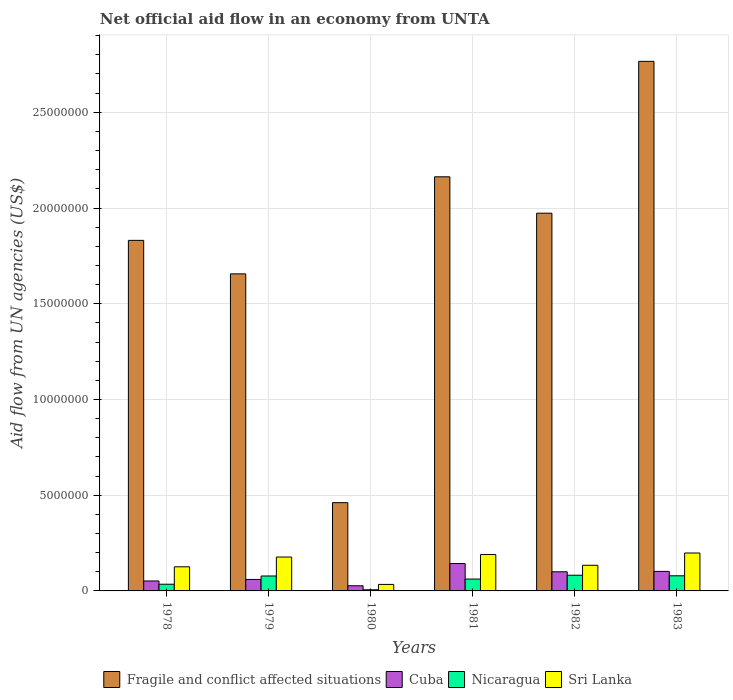Are the number of bars on each tick of the X-axis equal?
Offer a terse response. Yes. How many bars are there on the 5th tick from the left?
Give a very brief answer. 4. How many bars are there on the 3rd tick from the right?
Make the answer very short. 4. What is the label of the 2nd group of bars from the left?
Offer a terse response. 1979. What is the net official aid flow in Fragile and conflict affected situations in 1978?
Ensure brevity in your answer.  1.83e+07. Across all years, what is the maximum net official aid flow in Sri Lanka?
Give a very brief answer. 1.98e+06. Across all years, what is the minimum net official aid flow in Fragile and conflict affected situations?
Keep it short and to the point. 4.61e+06. In which year was the net official aid flow in Nicaragua maximum?
Provide a short and direct response. 1982. In which year was the net official aid flow in Nicaragua minimum?
Your answer should be compact. 1980. What is the total net official aid flow in Nicaragua in the graph?
Offer a very short reply. 3.42e+06. What is the difference between the net official aid flow in Nicaragua in 1980 and that in 1982?
Your answer should be compact. -7.60e+05. What is the difference between the net official aid flow in Fragile and conflict affected situations in 1980 and the net official aid flow in Cuba in 1979?
Provide a short and direct response. 4.01e+06. What is the average net official aid flow in Sri Lanka per year?
Your answer should be compact. 1.43e+06. In the year 1981, what is the difference between the net official aid flow in Cuba and net official aid flow in Fragile and conflict affected situations?
Offer a terse response. -2.02e+07. What is the ratio of the net official aid flow in Sri Lanka in 1980 to that in 1983?
Ensure brevity in your answer.  0.17. Is the net official aid flow in Sri Lanka in 1978 less than that in 1979?
Provide a succinct answer. Yes. What is the difference between the highest and the second highest net official aid flow in Sri Lanka?
Offer a very short reply. 8.00e+04. What is the difference between the highest and the lowest net official aid flow in Cuba?
Your response must be concise. 1.16e+06. Is the sum of the net official aid flow in Nicaragua in 1980 and 1981 greater than the maximum net official aid flow in Sri Lanka across all years?
Your response must be concise. No. Is it the case that in every year, the sum of the net official aid flow in Cuba and net official aid flow in Fragile and conflict affected situations is greater than the sum of net official aid flow in Sri Lanka and net official aid flow in Nicaragua?
Offer a terse response. No. What does the 2nd bar from the left in 1983 represents?
Your response must be concise. Cuba. What does the 1st bar from the right in 1981 represents?
Keep it short and to the point. Sri Lanka. How many bars are there?
Ensure brevity in your answer.  24. Are all the bars in the graph horizontal?
Your response must be concise. No. How many years are there in the graph?
Ensure brevity in your answer.  6. What is the difference between two consecutive major ticks on the Y-axis?
Give a very brief answer. 5.00e+06. Does the graph contain any zero values?
Your response must be concise. No. Does the graph contain grids?
Ensure brevity in your answer.  Yes. Where does the legend appear in the graph?
Make the answer very short. Bottom center. How many legend labels are there?
Keep it short and to the point. 4. How are the legend labels stacked?
Your answer should be compact. Horizontal. What is the title of the graph?
Provide a short and direct response. Net official aid flow in an economy from UNTA. Does "Guinea-Bissau" appear as one of the legend labels in the graph?
Your response must be concise. No. What is the label or title of the Y-axis?
Ensure brevity in your answer.  Aid flow from UN agencies (US$). What is the Aid flow from UN agencies (US$) of Fragile and conflict affected situations in 1978?
Offer a terse response. 1.83e+07. What is the Aid flow from UN agencies (US$) of Cuba in 1978?
Ensure brevity in your answer.  5.20e+05. What is the Aid flow from UN agencies (US$) of Sri Lanka in 1978?
Make the answer very short. 1.26e+06. What is the Aid flow from UN agencies (US$) of Fragile and conflict affected situations in 1979?
Ensure brevity in your answer.  1.66e+07. What is the Aid flow from UN agencies (US$) in Nicaragua in 1979?
Ensure brevity in your answer.  7.80e+05. What is the Aid flow from UN agencies (US$) in Sri Lanka in 1979?
Ensure brevity in your answer.  1.77e+06. What is the Aid flow from UN agencies (US$) in Fragile and conflict affected situations in 1980?
Make the answer very short. 4.61e+06. What is the Aid flow from UN agencies (US$) in Sri Lanka in 1980?
Your answer should be very brief. 3.40e+05. What is the Aid flow from UN agencies (US$) of Fragile and conflict affected situations in 1981?
Ensure brevity in your answer.  2.16e+07. What is the Aid flow from UN agencies (US$) in Cuba in 1981?
Keep it short and to the point. 1.43e+06. What is the Aid flow from UN agencies (US$) in Nicaragua in 1981?
Provide a succinct answer. 6.20e+05. What is the Aid flow from UN agencies (US$) of Sri Lanka in 1981?
Give a very brief answer. 1.90e+06. What is the Aid flow from UN agencies (US$) in Fragile and conflict affected situations in 1982?
Make the answer very short. 1.97e+07. What is the Aid flow from UN agencies (US$) in Cuba in 1982?
Provide a succinct answer. 1.00e+06. What is the Aid flow from UN agencies (US$) in Nicaragua in 1982?
Provide a succinct answer. 8.20e+05. What is the Aid flow from UN agencies (US$) of Sri Lanka in 1982?
Make the answer very short. 1.34e+06. What is the Aid flow from UN agencies (US$) of Fragile and conflict affected situations in 1983?
Your answer should be very brief. 2.77e+07. What is the Aid flow from UN agencies (US$) in Cuba in 1983?
Your answer should be very brief. 1.02e+06. What is the Aid flow from UN agencies (US$) of Nicaragua in 1983?
Keep it short and to the point. 7.90e+05. What is the Aid flow from UN agencies (US$) in Sri Lanka in 1983?
Keep it short and to the point. 1.98e+06. Across all years, what is the maximum Aid flow from UN agencies (US$) in Fragile and conflict affected situations?
Offer a very short reply. 2.77e+07. Across all years, what is the maximum Aid flow from UN agencies (US$) of Cuba?
Keep it short and to the point. 1.43e+06. Across all years, what is the maximum Aid flow from UN agencies (US$) in Nicaragua?
Offer a very short reply. 8.20e+05. Across all years, what is the maximum Aid flow from UN agencies (US$) in Sri Lanka?
Provide a succinct answer. 1.98e+06. Across all years, what is the minimum Aid flow from UN agencies (US$) in Fragile and conflict affected situations?
Your answer should be compact. 4.61e+06. Across all years, what is the minimum Aid flow from UN agencies (US$) of Nicaragua?
Provide a short and direct response. 6.00e+04. What is the total Aid flow from UN agencies (US$) of Fragile and conflict affected situations in the graph?
Your response must be concise. 1.08e+08. What is the total Aid flow from UN agencies (US$) in Cuba in the graph?
Offer a very short reply. 4.84e+06. What is the total Aid flow from UN agencies (US$) in Nicaragua in the graph?
Your answer should be compact. 3.42e+06. What is the total Aid flow from UN agencies (US$) in Sri Lanka in the graph?
Offer a very short reply. 8.59e+06. What is the difference between the Aid flow from UN agencies (US$) of Fragile and conflict affected situations in 1978 and that in 1979?
Make the answer very short. 1.75e+06. What is the difference between the Aid flow from UN agencies (US$) of Cuba in 1978 and that in 1979?
Your response must be concise. -8.00e+04. What is the difference between the Aid flow from UN agencies (US$) of Nicaragua in 1978 and that in 1979?
Provide a short and direct response. -4.30e+05. What is the difference between the Aid flow from UN agencies (US$) of Sri Lanka in 1978 and that in 1979?
Provide a succinct answer. -5.10e+05. What is the difference between the Aid flow from UN agencies (US$) of Fragile and conflict affected situations in 1978 and that in 1980?
Keep it short and to the point. 1.37e+07. What is the difference between the Aid flow from UN agencies (US$) in Sri Lanka in 1978 and that in 1980?
Ensure brevity in your answer.  9.20e+05. What is the difference between the Aid flow from UN agencies (US$) in Fragile and conflict affected situations in 1978 and that in 1981?
Your response must be concise. -3.32e+06. What is the difference between the Aid flow from UN agencies (US$) in Cuba in 1978 and that in 1981?
Make the answer very short. -9.10e+05. What is the difference between the Aid flow from UN agencies (US$) of Nicaragua in 1978 and that in 1981?
Make the answer very short. -2.70e+05. What is the difference between the Aid flow from UN agencies (US$) in Sri Lanka in 1978 and that in 1981?
Give a very brief answer. -6.40e+05. What is the difference between the Aid flow from UN agencies (US$) of Fragile and conflict affected situations in 1978 and that in 1982?
Give a very brief answer. -1.42e+06. What is the difference between the Aid flow from UN agencies (US$) of Cuba in 1978 and that in 1982?
Make the answer very short. -4.80e+05. What is the difference between the Aid flow from UN agencies (US$) in Nicaragua in 1978 and that in 1982?
Keep it short and to the point. -4.70e+05. What is the difference between the Aid flow from UN agencies (US$) in Fragile and conflict affected situations in 1978 and that in 1983?
Your answer should be compact. -9.35e+06. What is the difference between the Aid flow from UN agencies (US$) of Cuba in 1978 and that in 1983?
Your answer should be compact. -5.00e+05. What is the difference between the Aid flow from UN agencies (US$) in Nicaragua in 1978 and that in 1983?
Your answer should be compact. -4.40e+05. What is the difference between the Aid flow from UN agencies (US$) of Sri Lanka in 1978 and that in 1983?
Ensure brevity in your answer.  -7.20e+05. What is the difference between the Aid flow from UN agencies (US$) in Fragile and conflict affected situations in 1979 and that in 1980?
Offer a very short reply. 1.20e+07. What is the difference between the Aid flow from UN agencies (US$) of Nicaragua in 1979 and that in 1980?
Provide a short and direct response. 7.20e+05. What is the difference between the Aid flow from UN agencies (US$) of Sri Lanka in 1979 and that in 1980?
Make the answer very short. 1.43e+06. What is the difference between the Aid flow from UN agencies (US$) of Fragile and conflict affected situations in 1979 and that in 1981?
Your answer should be very brief. -5.07e+06. What is the difference between the Aid flow from UN agencies (US$) of Cuba in 1979 and that in 1981?
Your answer should be very brief. -8.30e+05. What is the difference between the Aid flow from UN agencies (US$) of Sri Lanka in 1979 and that in 1981?
Provide a short and direct response. -1.30e+05. What is the difference between the Aid flow from UN agencies (US$) in Fragile and conflict affected situations in 1979 and that in 1982?
Offer a very short reply. -3.17e+06. What is the difference between the Aid flow from UN agencies (US$) in Cuba in 1979 and that in 1982?
Provide a short and direct response. -4.00e+05. What is the difference between the Aid flow from UN agencies (US$) of Sri Lanka in 1979 and that in 1982?
Give a very brief answer. 4.30e+05. What is the difference between the Aid flow from UN agencies (US$) of Fragile and conflict affected situations in 1979 and that in 1983?
Your response must be concise. -1.11e+07. What is the difference between the Aid flow from UN agencies (US$) of Cuba in 1979 and that in 1983?
Offer a very short reply. -4.20e+05. What is the difference between the Aid flow from UN agencies (US$) in Nicaragua in 1979 and that in 1983?
Your response must be concise. -10000. What is the difference between the Aid flow from UN agencies (US$) in Fragile and conflict affected situations in 1980 and that in 1981?
Give a very brief answer. -1.70e+07. What is the difference between the Aid flow from UN agencies (US$) in Cuba in 1980 and that in 1981?
Ensure brevity in your answer.  -1.16e+06. What is the difference between the Aid flow from UN agencies (US$) of Nicaragua in 1980 and that in 1981?
Your answer should be very brief. -5.60e+05. What is the difference between the Aid flow from UN agencies (US$) of Sri Lanka in 1980 and that in 1981?
Offer a terse response. -1.56e+06. What is the difference between the Aid flow from UN agencies (US$) of Fragile and conflict affected situations in 1980 and that in 1982?
Ensure brevity in your answer.  -1.51e+07. What is the difference between the Aid flow from UN agencies (US$) in Cuba in 1980 and that in 1982?
Offer a terse response. -7.30e+05. What is the difference between the Aid flow from UN agencies (US$) of Nicaragua in 1980 and that in 1982?
Your response must be concise. -7.60e+05. What is the difference between the Aid flow from UN agencies (US$) in Fragile and conflict affected situations in 1980 and that in 1983?
Ensure brevity in your answer.  -2.30e+07. What is the difference between the Aid flow from UN agencies (US$) of Cuba in 1980 and that in 1983?
Provide a short and direct response. -7.50e+05. What is the difference between the Aid flow from UN agencies (US$) in Nicaragua in 1980 and that in 1983?
Provide a short and direct response. -7.30e+05. What is the difference between the Aid flow from UN agencies (US$) of Sri Lanka in 1980 and that in 1983?
Your answer should be compact. -1.64e+06. What is the difference between the Aid flow from UN agencies (US$) of Fragile and conflict affected situations in 1981 and that in 1982?
Your answer should be compact. 1.90e+06. What is the difference between the Aid flow from UN agencies (US$) in Cuba in 1981 and that in 1982?
Provide a short and direct response. 4.30e+05. What is the difference between the Aid flow from UN agencies (US$) in Nicaragua in 1981 and that in 1982?
Ensure brevity in your answer.  -2.00e+05. What is the difference between the Aid flow from UN agencies (US$) in Sri Lanka in 1981 and that in 1982?
Make the answer very short. 5.60e+05. What is the difference between the Aid flow from UN agencies (US$) in Fragile and conflict affected situations in 1981 and that in 1983?
Provide a succinct answer. -6.03e+06. What is the difference between the Aid flow from UN agencies (US$) of Sri Lanka in 1981 and that in 1983?
Your answer should be very brief. -8.00e+04. What is the difference between the Aid flow from UN agencies (US$) in Fragile and conflict affected situations in 1982 and that in 1983?
Provide a short and direct response. -7.93e+06. What is the difference between the Aid flow from UN agencies (US$) of Cuba in 1982 and that in 1983?
Your response must be concise. -2.00e+04. What is the difference between the Aid flow from UN agencies (US$) in Nicaragua in 1982 and that in 1983?
Offer a very short reply. 3.00e+04. What is the difference between the Aid flow from UN agencies (US$) in Sri Lanka in 1982 and that in 1983?
Offer a terse response. -6.40e+05. What is the difference between the Aid flow from UN agencies (US$) in Fragile and conflict affected situations in 1978 and the Aid flow from UN agencies (US$) in Cuba in 1979?
Offer a terse response. 1.77e+07. What is the difference between the Aid flow from UN agencies (US$) of Fragile and conflict affected situations in 1978 and the Aid flow from UN agencies (US$) of Nicaragua in 1979?
Your response must be concise. 1.75e+07. What is the difference between the Aid flow from UN agencies (US$) in Fragile and conflict affected situations in 1978 and the Aid flow from UN agencies (US$) in Sri Lanka in 1979?
Offer a very short reply. 1.65e+07. What is the difference between the Aid flow from UN agencies (US$) of Cuba in 1978 and the Aid flow from UN agencies (US$) of Nicaragua in 1979?
Make the answer very short. -2.60e+05. What is the difference between the Aid flow from UN agencies (US$) in Cuba in 1978 and the Aid flow from UN agencies (US$) in Sri Lanka in 1979?
Offer a terse response. -1.25e+06. What is the difference between the Aid flow from UN agencies (US$) in Nicaragua in 1978 and the Aid flow from UN agencies (US$) in Sri Lanka in 1979?
Your response must be concise. -1.42e+06. What is the difference between the Aid flow from UN agencies (US$) in Fragile and conflict affected situations in 1978 and the Aid flow from UN agencies (US$) in Cuba in 1980?
Offer a very short reply. 1.80e+07. What is the difference between the Aid flow from UN agencies (US$) in Fragile and conflict affected situations in 1978 and the Aid flow from UN agencies (US$) in Nicaragua in 1980?
Give a very brief answer. 1.82e+07. What is the difference between the Aid flow from UN agencies (US$) in Fragile and conflict affected situations in 1978 and the Aid flow from UN agencies (US$) in Sri Lanka in 1980?
Provide a short and direct response. 1.80e+07. What is the difference between the Aid flow from UN agencies (US$) in Cuba in 1978 and the Aid flow from UN agencies (US$) in Sri Lanka in 1980?
Ensure brevity in your answer.  1.80e+05. What is the difference between the Aid flow from UN agencies (US$) of Fragile and conflict affected situations in 1978 and the Aid flow from UN agencies (US$) of Cuba in 1981?
Provide a succinct answer. 1.69e+07. What is the difference between the Aid flow from UN agencies (US$) in Fragile and conflict affected situations in 1978 and the Aid flow from UN agencies (US$) in Nicaragua in 1981?
Keep it short and to the point. 1.77e+07. What is the difference between the Aid flow from UN agencies (US$) in Fragile and conflict affected situations in 1978 and the Aid flow from UN agencies (US$) in Sri Lanka in 1981?
Keep it short and to the point. 1.64e+07. What is the difference between the Aid flow from UN agencies (US$) in Cuba in 1978 and the Aid flow from UN agencies (US$) in Nicaragua in 1981?
Provide a short and direct response. -1.00e+05. What is the difference between the Aid flow from UN agencies (US$) in Cuba in 1978 and the Aid flow from UN agencies (US$) in Sri Lanka in 1981?
Provide a succinct answer. -1.38e+06. What is the difference between the Aid flow from UN agencies (US$) in Nicaragua in 1978 and the Aid flow from UN agencies (US$) in Sri Lanka in 1981?
Your answer should be very brief. -1.55e+06. What is the difference between the Aid flow from UN agencies (US$) of Fragile and conflict affected situations in 1978 and the Aid flow from UN agencies (US$) of Cuba in 1982?
Your answer should be compact. 1.73e+07. What is the difference between the Aid flow from UN agencies (US$) of Fragile and conflict affected situations in 1978 and the Aid flow from UN agencies (US$) of Nicaragua in 1982?
Your answer should be compact. 1.75e+07. What is the difference between the Aid flow from UN agencies (US$) of Fragile and conflict affected situations in 1978 and the Aid flow from UN agencies (US$) of Sri Lanka in 1982?
Offer a terse response. 1.70e+07. What is the difference between the Aid flow from UN agencies (US$) in Cuba in 1978 and the Aid flow from UN agencies (US$) in Nicaragua in 1982?
Keep it short and to the point. -3.00e+05. What is the difference between the Aid flow from UN agencies (US$) of Cuba in 1978 and the Aid flow from UN agencies (US$) of Sri Lanka in 1982?
Your response must be concise. -8.20e+05. What is the difference between the Aid flow from UN agencies (US$) in Nicaragua in 1978 and the Aid flow from UN agencies (US$) in Sri Lanka in 1982?
Ensure brevity in your answer.  -9.90e+05. What is the difference between the Aid flow from UN agencies (US$) of Fragile and conflict affected situations in 1978 and the Aid flow from UN agencies (US$) of Cuba in 1983?
Ensure brevity in your answer.  1.73e+07. What is the difference between the Aid flow from UN agencies (US$) in Fragile and conflict affected situations in 1978 and the Aid flow from UN agencies (US$) in Nicaragua in 1983?
Make the answer very short. 1.75e+07. What is the difference between the Aid flow from UN agencies (US$) in Fragile and conflict affected situations in 1978 and the Aid flow from UN agencies (US$) in Sri Lanka in 1983?
Your response must be concise. 1.63e+07. What is the difference between the Aid flow from UN agencies (US$) in Cuba in 1978 and the Aid flow from UN agencies (US$) in Nicaragua in 1983?
Ensure brevity in your answer.  -2.70e+05. What is the difference between the Aid flow from UN agencies (US$) of Cuba in 1978 and the Aid flow from UN agencies (US$) of Sri Lanka in 1983?
Provide a short and direct response. -1.46e+06. What is the difference between the Aid flow from UN agencies (US$) in Nicaragua in 1978 and the Aid flow from UN agencies (US$) in Sri Lanka in 1983?
Make the answer very short. -1.63e+06. What is the difference between the Aid flow from UN agencies (US$) of Fragile and conflict affected situations in 1979 and the Aid flow from UN agencies (US$) of Cuba in 1980?
Offer a terse response. 1.63e+07. What is the difference between the Aid flow from UN agencies (US$) in Fragile and conflict affected situations in 1979 and the Aid flow from UN agencies (US$) in Nicaragua in 1980?
Your answer should be very brief. 1.65e+07. What is the difference between the Aid flow from UN agencies (US$) in Fragile and conflict affected situations in 1979 and the Aid flow from UN agencies (US$) in Sri Lanka in 1980?
Your answer should be compact. 1.62e+07. What is the difference between the Aid flow from UN agencies (US$) of Cuba in 1979 and the Aid flow from UN agencies (US$) of Nicaragua in 1980?
Provide a short and direct response. 5.40e+05. What is the difference between the Aid flow from UN agencies (US$) in Cuba in 1979 and the Aid flow from UN agencies (US$) in Sri Lanka in 1980?
Offer a very short reply. 2.60e+05. What is the difference between the Aid flow from UN agencies (US$) of Nicaragua in 1979 and the Aid flow from UN agencies (US$) of Sri Lanka in 1980?
Provide a succinct answer. 4.40e+05. What is the difference between the Aid flow from UN agencies (US$) of Fragile and conflict affected situations in 1979 and the Aid flow from UN agencies (US$) of Cuba in 1981?
Your response must be concise. 1.51e+07. What is the difference between the Aid flow from UN agencies (US$) of Fragile and conflict affected situations in 1979 and the Aid flow from UN agencies (US$) of Nicaragua in 1981?
Make the answer very short. 1.59e+07. What is the difference between the Aid flow from UN agencies (US$) in Fragile and conflict affected situations in 1979 and the Aid flow from UN agencies (US$) in Sri Lanka in 1981?
Your answer should be very brief. 1.47e+07. What is the difference between the Aid flow from UN agencies (US$) of Cuba in 1979 and the Aid flow from UN agencies (US$) of Sri Lanka in 1981?
Give a very brief answer. -1.30e+06. What is the difference between the Aid flow from UN agencies (US$) in Nicaragua in 1979 and the Aid flow from UN agencies (US$) in Sri Lanka in 1981?
Offer a very short reply. -1.12e+06. What is the difference between the Aid flow from UN agencies (US$) of Fragile and conflict affected situations in 1979 and the Aid flow from UN agencies (US$) of Cuba in 1982?
Your answer should be compact. 1.56e+07. What is the difference between the Aid flow from UN agencies (US$) in Fragile and conflict affected situations in 1979 and the Aid flow from UN agencies (US$) in Nicaragua in 1982?
Provide a succinct answer. 1.57e+07. What is the difference between the Aid flow from UN agencies (US$) in Fragile and conflict affected situations in 1979 and the Aid flow from UN agencies (US$) in Sri Lanka in 1982?
Your answer should be very brief. 1.52e+07. What is the difference between the Aid flow from UN agencies (US$) of Cuba in 1979 and the Aid flow from UN agencies (US$) of Nicaragua in 1982?
Offer a terse response. -2.20e+05. What is the difference between the Aid flow from UN agencies (US$) in Cuba in 1979 and the Aid flow from UN agencies (US$) in Sri Lanka in 1982?
Your answer should be compact. -7.40e+05. What is the difference between the Aid flow from UN agencies (US$) of Nicaragua in 1979 and the Aid flow from UN agencies (US$) of Sri Lanka in 1982?
Keep it short and to the point. -5.60e+05. What is the difference between the Aid flow from UN agencies (US$) in Fragile and conflict affected situations in 1979 and the Aid flow from UN agencies (US$) in Cuba in 1983?
Your answer should be compact. 1.55e+07. What is the difference between the Aid flow from UN agencies (US$) in Fragile and conflict affected situations in 1979 and the Aid flow from UN agencies (US$) in Nicaragua in 1983?
Your answer should be very brief. 1.58e+07. What is the difference between the Aid flow from UN agencies (US$) of Fragile and conflict affected situations in 1979 and the Aid flow from UN agencies (US$) of Sri Lanka in 1983?
Your response must be concise. 1.46e+07. What is the difference between the Aid flow from UN agencies (US$) in Cuba in 1979 and the Aid flow from UN agencies (US$) in Sri Lanka in 1983?
Make the answer very short. -1.38e+06. What is the difference between the Aid flow from UN agencies (US$) in Nicaragua in 1979 and the Aid flow from UN agencies (US$) in Sri Lanka in 1983?
Provide a succinct answer. -1.20e+06. What is the difference between the Aid flow from UN agencies (US$) in Fragile and conflict affected situations in 1980 and the Aid flow from UN agencies (US$) in Cuba in 1981?
Your answer should be very brief. 3.18e+06. What is the difference between the Aid flow from UN agencies (US$) in Fragile and conflict affected situations in 1980 and the Aid flow from UN agencies (US$) in Nicaragua in 1981?
Offer a very short reply. 3.99e+06. What is the difference between the Aid flow from UN agencies (US$) of Fragile and conflict affected situations in 1980 and the Aid flow from UN agencies (US$) of Sri Lanka in 1981?
Make the answer very short. 2.71e+06. What is the difference between the Aid flow from UN agencies (US$) of Cuba in 1980 and the Aid flow from UN agencies (US$) of Nicaragua in 1981?
Give a very brief answer. -3.50e+05. What is the difference between the Aid flow from UN agencies (US$) in Cuba in 1980 and the Aid flow from UN agencies (US$) in Sri Lanka in 1981?
Your response must be concise. -1.63e+06. What is the difference between the Aid flow from UN agencies (US$) in Nicaragua in 1980 and the Aid flow from UN agencies (US$) in Sri Lanka in 1981?
Give a very brief answer. -1.84e+06. What is the difference between the Aid flow from UN agencies (US$) in Fragile and conflict affected situations in 1980 and the Aid flow from UN agencies (US$) in Cuba in 1982?
Keep it short and to the point. 3.61e+06. What is the difference between the Aid flow from UN agencies (US$) in Fragile and conflict affected situations in 1980 and the Aid flow from UN agencies (US$) in Nicaragua in 1982?
Provide a short and direct response. 3.79e+06. What is the difference between the Aid flow from UN agencies (US$) of Fragile and conflict affected situations in 1980 and the Aid flow from UN agencies (US$) of Sri Lanka in 1982?
Your response must be concise. 3.27e+06. What is the difference between the Aid flow from UN agencies (US$) of Cuba in 1980 and the Aid flow from UN agencies (US$) of Nicaragua in 1982?
Your answer should be compact. -5.50e+05. What is the difference between the Aid flow from UN agencies (US$) of Cuba in 1980 and the Aid flow from UN agencies (US$) of Sri Lanka in 1982?
Your response must be concise. -1.07e+06. What is the difference between the Aid flow from UN agencies (US$) in Nicaragua in 1980 and the Aid flow from UN agencies (US$) in Sri Lanka in 1982?
Your answer should be compact. -1.28e+06. What is the difference between the Aid flow from UN agencies (US$) of Fragile and conflict affected situations in 1980 and the Aid flow from UN agencies (US$) of Cuba in 1983?
Your answer should be very brief. 3.59e+06. What is the difference between the Aid flow from UN agencies (US$) in Fragile and conflict affected situations in 1980 and the Aid flow from UN agencies (US$) in Nicaragua in 1983?
Make the answer very short. 3.82e+06. What is the difference between the Aid flow from UN agencies (US$) in Fragile and conflict affected situations in 1980 and the Aid flow from UN agencies (US$) in Sri Lanka in 1983?
Keep it short and to the point. 2.63e+06. What is the difference between the Aid flow from UN agencies (US$) of Cuba in 1980 and the Aid flow from UN agencies (US$) of Nicaragua in 1983?
Make the answer very short. -5.20e+05. What is the difference between the Aid flow from UN agencies (US$) in Cuba in 1980 and the Aid flow from UN agencies (US$) in Sri Lanka in 1983?
Keep it short and to the point. -1.71e+06. What is the difference between the Aid flow from UN agencies (US$) in Nicaragua in 1980 and the Aid flow from UN agencies (US$) in Sri Lanka in 1983?
Your response must be concise. -1.92e+06. What is the difference between the Aid flow from UN agencies (US$) of Fragile and conflict affected situations in 1981 and the Aid flow from UN agencies (US$) of Cuba in 1982?
Provide a short and direct response. 2.06e+07. What is the difference between the Aid flow from UN agencies (US$) of Fragile and conflict affected situations in 1981 and the Aid flow from UN agencies (US$) of Nicaragua in 1982?
Provide a short and direct response. 2.08e+07. What is the difference between the Aid flow from UN agencies (US$) of Fragile and conflict affected situations in 1981 and the Aid flow from UN agencies (US$) of Sri Lanka in 1982?
Provide a short and direct response. 2.03e+07. What is the difference between the Aid flow from UN agencies (US$) of Cuba in 1981 and the Aid flow from UN agencies (US$) of Nicaragua in 1982?
Ensure brevity in your answer.  6.10e+05. What is the difference between the Aid flow from UN agencies (US$) of Nicaragua in 1981 and the Aid flow from UN agencies (US$) of Sri Lanka in 1982?
Provide a succinct answer. -7.20e+05. What is the difference between the Aid flow from UN agencies (US$) of Fragile and conflict affected situations in 1981 and the Aid flow from UN agencies (US$) of Cuba in 1983?
Give a very brief answer. 2.06e+07. What is the difference between the Aid flow from UN agencies (US$) of Fragile and conflict affected situations in 1981 and the Aid flow from UN agencies (US$) of Nicaragua in 1983?
Offer a terse response. 2.08e+07. What is the difference between the Aid flow from UN agencies (US$) of Fragile and conflict affected situations in 1981 and the Aid flow from UN agencies (US$) of Sri Lanka in 1983?
Offer a terse response. 1.96e+07. What is the difference between the Aid flow from UN agencies (US$) in Cuba in 1981 and the Aid flow from UN agencies (US$) in Nicaragua in 1983?
Make the answer very short. 6.40e+05. What is the difference between the Aid flow from UN agencies (US$) in Cuba in 1981 and the Aid flow from UN agencies (US$) in Sri Lanka in 1983?
Give a very brief answer. -5.50e+05. What is the difference between the Aid flow from UN agencies (US$) in Nicaragua in 1981 and the Aid flow from UN agencies (US$) in Sri Lanka in 1983?
Give a very brief answer. -1.36e+06. What is the difference between the Aid flow from UN agencies (US$) of Fragile and conflict affected situations in 1982 and the Aid flow from UN agencies (US$) of Cuba in 1983?
Offer a terse response. 1.87e+07. What is the difference between the Aid flow from UN agencies (US$) of Fragile and conflict affected situations in 1982 and the Aid flow from UN agencies (US$) of Nicaragua in 1983?
Provide a succinct answer. 1.89e+07. What is the difference between the Aid flow from UN agencies (US$) in Fragile and conflict affected situations in 1982 and the Aid flow from UN agencies (US$) in Sri Lanka in 1983?
Offer a very short reply. 1.78e+07. What is the difference between the Aid flow from UN agencies (US$) in Cuba in 1982 and the Aid flow from UN agencies (US$) in Sri Lanka in 1983?
Offer a very short reply. -9.80e+05. What is the difference between the Aid flow from UN agencies (US$) of Nicaragua in 1982 and the Aid flow from UN agencies (US$) of Sri Lanka in 1983?
Provide a short and direct response. -1.16e+06. What is the average Aid flow from UN agencies (US$) of Fragile and conflict affected situations per year?
Provide a succinct answer. 1.81e+07. What is the average Aid flow from UN agencies (US$) of Cuba per year?
Your response must be concise. 8.07e+05. What is the average Aid flow from UN agencies (US$) in Nicaragua per year?
Your answer should be very brief. 5.70e+05. What is the average Aid flow from UN agencies (US$) of Sri Lanka per year?
Offer a very short reply. 1.43e+06. In the year 1978, what is the difference between the Aid flow from UN agencies (US$) of Fragile and conflict affected situations and Aid flow from UN agencies (US$) of Cuba?
Your response must be concise. 1.78e+07. In the year 1978, what is the difference between the Aid flow from UN agencies (US$) in Fragile and conflict affected situations and Aid flow from UN agencies (US$) in Nicaragua?
Ensure brevity in your answer.  1.80e+07. In the year 1978, what is the difference between the Aid flow from UN agencies (US$) of Fragile and conflict affected situations and Aid flow from UN agencies (US$) of Sri Lanka?
Keep it short and to the point. 1.70e+07. In the year 1978, what is the difference between the Aid flow from UN agencies (US$) of Cuba and Aid flow from UN agencies (US$) of Nicaragua?
Your answer should be very brief. 1.70e+05. In the year 1978, what is the difference between the Aid flow from UN agencies (US$) of Cuba and Aid flow from UN agencies (US$) of Sri Lanka?
Give a very brief answer. -7.40e+05. In the year 1978, what is the difference between the Aid flow from UN agencies (US$) in Nicaragua and Aid flow from UN agencies (US$) in Sri Lanka?
Offer a very short reply. -9.10e+05. In the year 1979, what is the difference between the Aid flow from UN agencies (US$) in Fragile and conflict affected situations and Aid flow from UN agencies (US$) in Cuba?
Provide a succinct answer. 1.60e+07. In the year 1979, what is the difference between the Aid flow from UN agencies (US$) of Fragile and conflict affected situations and Aid flow from UN agencies (US$) of Nicaragua?
Keep it short and to the point. 1.58e+07. In the year 1979, what is the difference between the Aid flow from UN agencies (US$) of Fragile and conflict affected situations and Aid flow from UN agencies (US$) of Sri Lanka?
Keep it short and to the point. 1.48e+07. In the year 1979, what is the difference between the Aid flow from UN agencies (US$) of Cuba and Aid flow from UN agencies (US$) of Nicaragua?
Make the answer very short. -1.80e+05. In the year 1979, what is the difference between the Aid flow from UN agencies (US$) in Cuba and Aid flow from UN agencies (US$) in Sri Lanka?
Provide a short and direct response. -1.17e+06. In the year 1979, what is the difference between the Aid flow from UN agencies (US$) of Nicaragua and Aid flow from UN agencies (US$) of Sri Lanka?
Your answer should be very brief. -9.90e+05. In the year 1980, what is the difference between the Aid flow from UN agencies (US$) in Fragile and conflict affected situations and Aid flow from UN agencies (US$) in Cuba?
Provide a succinct answer. 4.34e+06. In the year 1980, what is the difference between the Aid flow from UN agencies (US$) in Fragile and conflict affected situations and Aid flow from UN agencies (US$) in Nicaragua?
Provide a succinct answer. 4.55e+06. In the year 1980, what is the difference between the Aid flow from UN agencies (US$) of Fragile and conflict affected situations and Aid flow from UN agencies (US$) of Sri Lanka?
Offer a terse response. 4.27e+06. In the year 1980, what is the difference between the Aid flow from UN agencies (US$) in Cuba and Aid flow from UN agencies (US$) in Sri Lanka?
Offer a terse response. -7.00e+04. In the year 1980, what is the difference between the Aid flow from UN agencies (US$) in Nicaragua and Aid flow from UN agencies (US$) in Sri Lanka?
Keep it short and to the point. -2.80e+05. In the year 1981, what is the difference between the Aid flow from UN agencies (US$) of Fragile and conflict affected situations and Aid flow from UN agencies (US$) of Cuba?
Your response must be concise. 2.02e+07. In the year 1981, what is the difference between the Aid flow from UN agencies (US$) of Fragile and conflict affected situations and Aid flow from UN agencies (US$) of Nicaragua?
Your response must be concise. 2.10e+07. In the year 1981, what is the difference between the Aid flow from UN agencies (US$) of Fragile and conflict affected situations and Aid flow from UN agencies (US$) of Sri Lanka?
Provide a short and direct response. 1.97e+07. In the year 1981, what is the difference between the Aid flow from UN agencies (US$) in Cuba and Aid flow from UN agencies (US$) in Nicaragua?
Give a very brief answer. 8.10e+05. In the year 1981, what is the difference between the Aid flow from UN agencies (US$) in Cuba and Aid flow from UN agencies (US$) in Sri Lanka?
Your response must be concise. -4.70e+05. In the year 1981, what is the difference between the Aid flow from UN agencies (US$) in Nicaragua and Aid flow from UN agencies (US$) in Sri Lanka?
Your answer should be very brief. -1.28e+06. In the year 1982, what is the difference between the Aid flow from UN agencies (US$) in Fragile and conflict affected situations and Aid flow from UN agencies (US$) in Cuba?
Offer a very short reply. 1.87e+07. In the year 1982, what is the difference between the Aid flow from UN agencies (US$) of Fragile and conflict affected situations and Aid flow from UN agencies (US$) of Nicaragua?
Give a very brief answer. 1.89e+07. In the year 1982, what is the difference between the Aid flow from UN agencies (US$) of Fragile and conflict affected situations and Aid flow from UN agencies (US$) of Sri Lanka?
Your answer should be compact. 1.84e+07. In the year 1982, what is the difference between the Aid flow from UN agencies (US$) of Cuba and Aid flow from UN agencies (US$) of Nicaragua?
Give a very brief answer. 1.80e+05. In the year 1982, what is the difference between the Aid flow from UN agencies (US$) of Cuba and Aid flow from UN agencies (US$) of Sri Lanka?
Offer a very short reply. -3.40e+05. In the year 1982, what is the difference between the Aid flow from UN agencies (US$) of Nicaragua and Aid flow from UN agencies (US$) of Sri Lanka?
Ensure brevity in your answer.  -5.20e+05. In the year 1983, what is the difference between the Aid flow from UN agencies (US$) of Fragile and conflict affected situations and Aid flow from UN agencies (US$) of Cuba?
Offer a very short reply. 2.66e+07. In the year 1983, what is the difference between the Aid flow from UN agencies (US$) of Fragile and conflict affected situations and Aid flow from UN agencies (US$) of Nicaragua?
Make the answer very short. 2.69e+07. In the year 1983, what is the difference between the Aid flow from UN agencies (US$) of Fragile and conflict affected situations and Aid flow from UN agencies (US$) of Sri Lanka?
Give a very brief answer. 2.57e+07. In the year 1983, what is the difference between the Aid flow from UN agencies (US$) in Cuba and Aid flow from UN agencies (US$) in Sri Lanka?
Provide a succinct answer. -9.60e+05. In the year 1983, what is the difference between the Aid flow from UN agencies (US$) in Nicaragua and Aid flow from UN agencies (US$) in Sri Lanka?
Make the answer very short. -1.19e+06. What is the ratio of the Aid flow from UN agencies (US$) in Fragile and conflict affected situations in 1978 to that in 1979?
Your answer should be compact. 1.11. What is the ratio of the Aid flow from UN agencies (US$) of Cuba in 1978 to that in 1979?
Offer a terse response. 0.87. What is the ratio of the Aid flow from UN agencies (US$) of Nicaragua in 1978 to that in 1979?
Ensure brevity in your answer.  0.45. What is the ratio of the Aid flow from UN agencies (US$) in Sri Lanka in 1978 to that in 1979?
Make the answer very short. 0.71. What is the ratio of the Aid flow from UN agencies (US$) of Fragile and conflict affected situations in 1978 to that in 1980?
Offer a terse response. 3.97. What is the ratio of the Aid flow from UN agencies (US$) in Cuba in 1978 to that in 1980?
Your answer should be compact. 1.93. What is the ratio of the Aid flow from UN agencies (US$) in Nicaragua in 1978 to that in 1980?
Your response must be concise. 5.83. What is the ratio of the Aid flow from UN agencies (US$) of Sri Lanka in 1978 to that in 1980?
Ensure brevity in your answer.  3.71. What is the ratio of the Aid flow from UN agencies (US$) in Fragile and conflict affected situations in 1978 to that in 1981?
Offer a very short reply. 0.85. What is the ratio of the Aid flow from UN agencies (US$) in Cuba in 1978 to that in 1981?
Provide a short and direct response. 0.36. What is the ratio of the Aid flow from UN agencies (US$) of Nicaragua in 1978 to that in 1981?
Offer a very short reply. 0.56. What is the ratio of the Aid flow from UN agencies (US$) of Sri Lanka in 1978 to that in 1981?
Ensure brevity in your answer.  0.66. What is the ratio of the Aid flow from UN agencies (US$) of Fragile and conflict affected situations in 1978 to that in 1982?
Provide a succinct answer. 0.93. What is the ratio of the Aid flow from UN agencies (US$) in Cuba in 1978 to that in 1982?
Your answer should be compact. 0.52. What is the ratio of the Aid flow from UN agencies (US$) of Nicaragua in 1978 to that in 1982?
Keep it short and to the point. 0.43. What is the ratio of the Aid flow from UN agencies (US$) in Sri Lanka in 1978 to that in 1982?
Your answer should be very brief. 0.94. What is the ratio of the Aid flow from UN agencies (US$) of Fragile and conflict affected situations in 1978 to that in 1983?
Your response must be concise. 0.66. What is the ratio of the Aid flow from UN agencies (US$) in Cuba in 1978 to that in 1983?
Provide a short and direct response. 0.51. What is the ratio of the Aid flow from UN agencies (US$) of Nicaragua in 1978 to that in 1983?
Offer a very short reply. 0.44. What is the ratio of the Aid flow from UN agencies (US$) of Sri Lanka in 1978 to that in 1983?
Provide a short and direct response. 0.64. What is the ratio of the Aid flow from UN agencies (US$) of Fragile and conflict affected situations in 1979 to that in 1980?
Keep it short and to the point. 3.59. What is the ratio of the Aid flow from UN agencies (US$) in Cuba in 1979 to that in 1980?
Make the answer very short. 2.22. What is the ratio of the Aid flow from UN agencies (US$) of Nicaragua in 1979 to that in 1980?
Give a very brief answer. 13. What is the ratio of the Aid flow from UN agencies (US$) of Sri Lanka in 1979 to that in 1980?
Ensure brevity in your answer.  5.21. What is the ratio of the Aid flow from UN agencies (US$) of Fragile and conflict affected situations in 1979 to that in 1981?
Make the answer very short. 0.77. What is the ratio of the Aid flow from UN agencies (US$) in Cuba in 1979 to that in 1981?
Your response must be concise. 0.42. What is the ratio of the Aid flow from UN agencies (US$) of Nicaragua in 1979 to that in 1981?
Make the answer very short. 1.26. What is the ratio of the Aid flow from UN agencies (US$) of Sri Lanka in 1979 to that in 1981?
Offer a terse response. 0.93. What is the ratio of the Aid flow from UN agencies (US$) in Fragile and conflict affected situations in 1979 to that in 1982?
Your answer should be very brief. 0.84. What is the ratio of the Aid flow from UN agencies (US$) in Nicaragua in 1979 to that in 1982?
Your answer should be compact. 0.95. What is the ratio of the Aid flow from UN agencies (US$) of Sri Lanka in 1979 to that in 1982?
Provide a succinct answer. 1.32. What is the ratio of the Aid flow from UN agencies (US$) in Fragile and conflict affected situations in 1979 to that in 1983?
Provide a short and direct response. 0.6. What is the ratio of the Aid flow from UN agencies (US$) in Cuba in 1979 to that in 1983?
Make the answer very short. 0.59. What is the ratio of the Aid flow from UN agencies (US$) of Nicaragua in 1979 to that in 1983?
Your answer should be compact. 0.99. What is the ratio of the Aid flow from UN agencies (US$) of Sri Lanka in 1979 to that in 1983?
Your answer should be very brief. 0.89. What is the ratio of the Aid flow from UN agencies (US$) of Fragile and conflict affected situations in 1980 to that in 1981?
Keep it short and to the point. 0.21. What is the ratio of the Aid flow from UN agencies (US$) in Cuba in 1980 to that in 1981?
Your response must be concise. 0.19. What is the ratio of the Aid flow from UN agencies (US$) of Nicaragua in 1980 to that in 1981?
Your answer should be very brief. 0.1. What is the ratio of the Aid flow from UN agencies (US$) in Sri Lanka in 1980 to that in 1981?
Give a very brief answer. 0.18. What is the ratio of the Aid flow from UN agencies (US$) of Fragile and conflict affected situations in 1980 to that in 1982?
Ensure brevity in your answer.  0.23. What is the ratio of the Aid flow from UN agencies (US$) of Cuba in 1980 to that in 1982?
Offer a terse response. 0.27. What is the ratio of the Aid flow from UN agencies (US$) of Nicaragua in 1980 to that in 1982?
Your response must be concise. 0.07. What is the ratio of the Aid flow from UN agencies (US$) of Sri Lanka in 1980 to that in 1982?
Give a very brief answer. 0.25. What is the ratio of the Aid flow from UN agencies (US$) in Fragile and conflict affected situations in 1980 to that in 1983?
Provide a short and direct response. 0.17. What is the ratio of the Aid flow from UN agencies (US$) in Cuba in 1980 to that in 1983?
Provide a short and direct response. 0.26. What is the ratio of the Aid flow from UN agencies (US$) of Nicaragua in 1980 to that in 1983?
Offer a terse response. 0.08. What is the ratio of the Aid flow from UN agencies (US$) in Sri Lanka in 1980 to that in 1983?
Provide a short and direct response. 0.17. What is the ratio of the Aid flow from UN agencies (US$) of Fragile and conflict affected situations in 1981 to that in 1982?
Provide a succinct answer. 1.1. What is the ratio of the Aid flow from UN agencies (US$) in Cuba in 1981 to that in 1982?
Your answer should be compact. 1.43. What is the ratio of the Aid flow from UN agencies (US$) in Nicaragua in 1981 to that in 1982?
Your answer should be very brief. 0.76. What is the ratio of the Aid flow from UN agencies (US$) in Sri Lanka in 1981 to that in 1982?
Offer a terse response. 1.42. What is the ratio of the Aid flow from UN agencies (US$) of Fragile and conflict affected situations in 1981 to that in 1983?
Provide a succinct answer. 0.78. What is the ratio of the Aid flow from UN agencies (US$) in Cuba in 1981 to that in 1983?
Make the answer very short. 1.4. What is the ratio of the Aid flow from UN agencies (US$) of Nicaragua in 1981 to that in 1983?
Give a very brief answer. 0.78. What is the ratio of the Aid flow from UN agencies (US$) in Sri Lanka in 1981 to that in 1983?
Keep it short and to the point. 0.96. What is the ratio of the Aid flow from UN agencies (US$) in Fragile and conflict affected situations in 1982 to that in 1983?
Ensure brevity in your answer.  0.71. What is the ratio of the Aid flow from UN agencies (US$) in Cuba in 1982 to that in 1983?
Offer a very short reply. 0.98. What is the ratio of the Aid flow from UN agencies (US$) of Nicaragua in 1982 to that in 1983?
Give a very brief answer. 1.04. What is the ratio of the Aid flow from UN agencies (US$) in Sri Lanka in 1982 to that in 1983?
Your answer should be compact. 0.68. What is the difference between the highest and the second highest Aid flow from UN agencies (US$) in Fragile and conflict affected situations?
Offer a terse response. 6.03e+06. What is the difference between the highest and the second highest Aid flow from UN agencies (US$) in Nicaragua?
Provide a succinct answer. 3.00e+04. What is the difference between the highest and the lowest Aid flow from UN agencies (US$) in Fragile and conflict affected situations?
Provide a succinct answer. 2.30e+07. What is the difference between the highest and the lowest Aid flow from UN agencies (US$) of Cuba?
Provide a succinct answer. 1.16e+06. What is the difference between the highest and the lowest Aid flow from UN agencies (US$) of Nicaragua?
Your response must be concise. 7.60e+05. What is the difference between the highest and the lowest Aid flow from UN agencies (US$) in Sri Lanka?
Provide a succinct answer. 1.64e+06. 